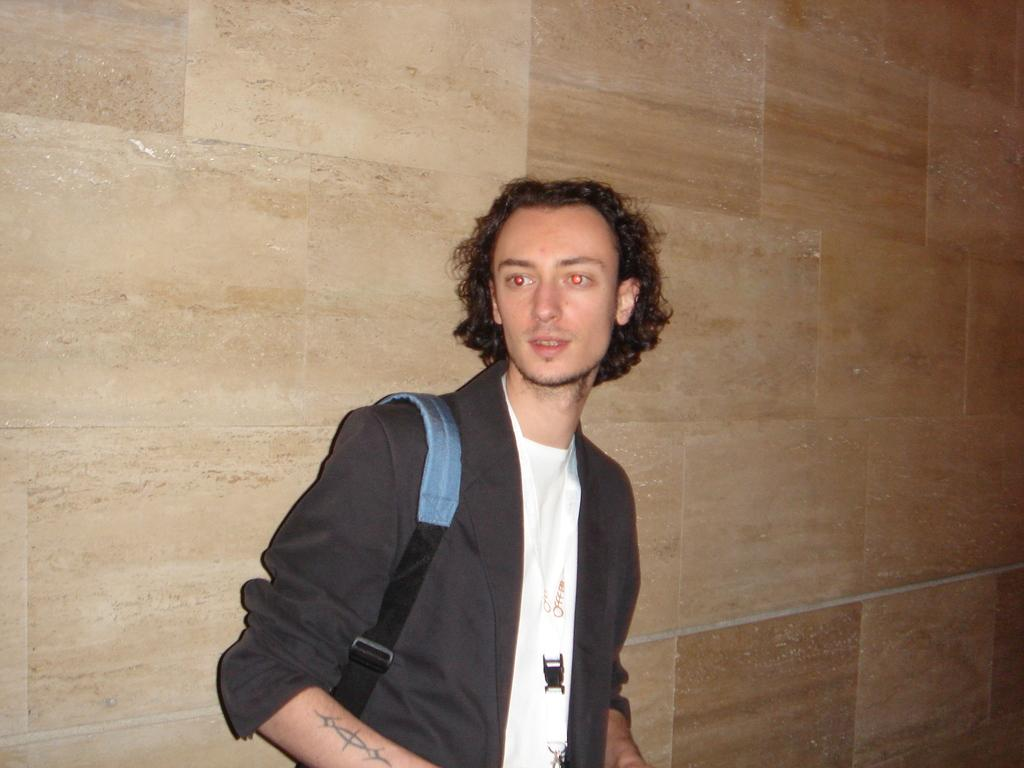Where was the image taken? The image was taken indoors. What can be seen in the background of the image? There is a wall in the background of the image. Who is the main subject in the image? There is a man in the middle of the image. What type of humor can be seen in the image? There is no humor present in the image; it is a straightforward photograph of a man indoors with a wall in the background. 